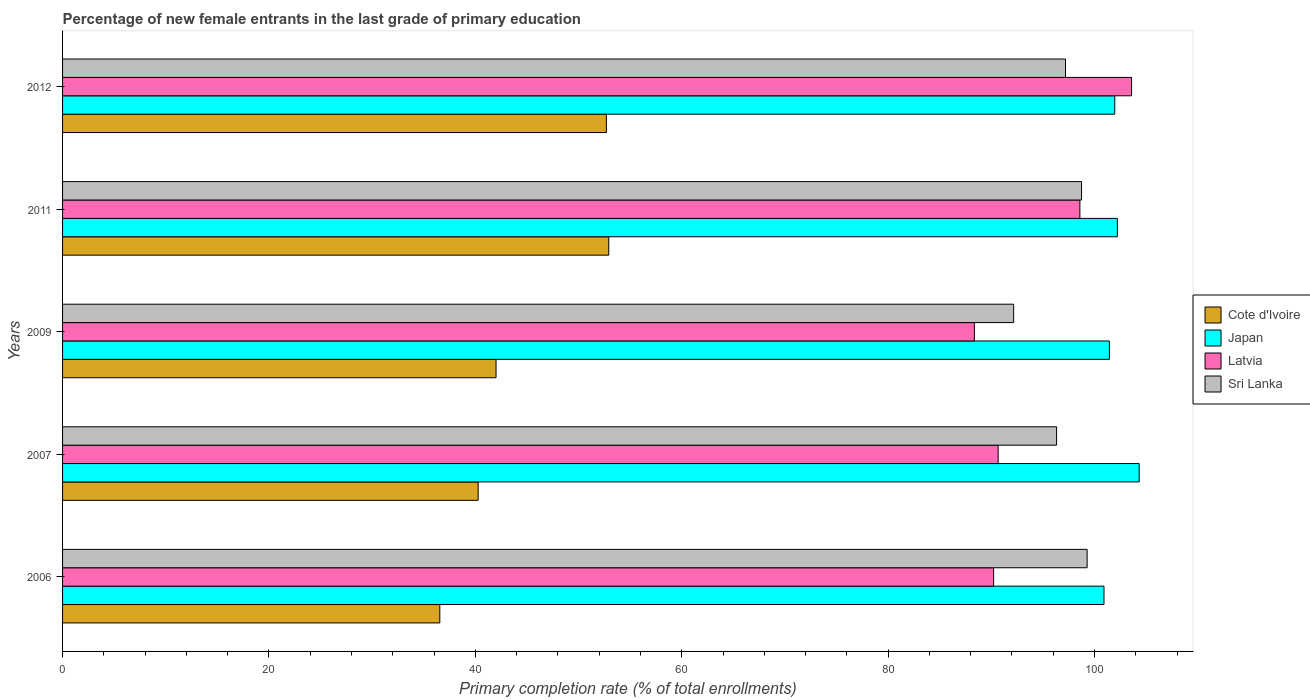How many different coloured bars are there?
Give a very brief answer. 4. Are the number of bars on each tick of the Y-axis equal?
Provide a succinct answer. Yes. How many bars are there on the 2nd tick from the top?
Provide a succinct answer. 4. How many bars are there on the 3rd tick from the bottom?
Your response must be concise. 4. What is the label of the 5th group of bars from the top?
Make the answer very short. 2006. What is the percentage of new female entrants in Japan in 2007?
Your answer should be compact. 104.33. Across all years, what is the maximum percentage of new female entrants in Cote d'Ivoire?
Ensure brevity in your answer.  52.93. Across all years, what is the minimum percentage of new female entrants in Japan?
Give a very brief answer. 100.92. In which year was the percentage of new female entrants in Sri Lanka maximum?
Your answer should be very brief. 2006. What is the total percentage of new female entrants in Japan in the graph?
Offer a terse response. 510.86. What is the difference between the percentage of new female entrants in Latvia in 2006 and that in 2009?
Offer a terse response. 1.86. What is the difference between the percentage of new female entrants in Cote d'Ivoire in 2006 and the percentage of new female entrants in Japan in 2009?
Keep it short and to the point. -64.89. What is the average percentage of new female entrants in Japan per year?
Ensure brevity in your answer.  102.17. In the year 2006, what is the difference between the percentage of new female entrants in Latvia and percentage of new female entrants in Sri Lanka?
Make the answer very short. -9.06. What is the ratio of the percentage of new female entrants in Japan in 2009 to that in 2011?
Provide a short and direct response. 0.99. Is the percentage of new female entrants in Cote d'Ivoire in 2006 less than that in 2009?
Make the answer very short. Yes. Is the difference between the percentage of new female entrants in Latvia in 2009 and 2012 greater than the difference between the percentage of new female entrants in Sri Lanka in 2009 and 2012?
Your answer should be compact. No. What is the difference between the highest and the second highest percentage of new female entrants in Latvia?
Provide a short and direct response. 5.01. What is the difference between the highest and the lowest percentage of new female entrants in Sri Lanka?
Provide a short and direct response. 7.12. In how many years, is the percentage of new female entrants in Sri Lanka greater than the average percentage of new female entrants in Sri Lanka taken over all years?
Offer a terse response. 3. What does the 4th bar from the top in 2011 represents?
Ensure brevity in your answer.  Cote d'Ivoire. What does the 3rd bar from the bottom in 2006 represents?
Provide a short and direct response. Latvia. Is it the case that in every year, the sum of the percentage of new female entrants in Cote d'Ivoire and percentage of new female entrants in Japan is greater than the percentage of new female entrants in Sri Lanka?
Make the answer very short. Yes. How many years are there in the graph?
Keep it short and to the point. 5. What is the difference between two consecutive major ticks on the X-axis?
Ensure brevity in your answer.  20. Are the values on the major ticks of X-axis written in scientific E-notation?
Keep it short and to the point. No. Does the graph contain any zero values?
Offer a terse response. No. Does the graph contain grids?
Offer a terse response. No. How are the legend labels stacked?
Keep it short and to the point. Vertical. What is the title of the graph?
Provide a succinct answer. Percentage of new female entrants in the last grade of primary education. What is the label or title of the X-axis?
Offer a very short reply. Primary completion rate (% of total enrollments). What is the label or title of the Y-axis?
Your answer should be compact. Years. What is the Primary completion rate (% of total enrollments) in Cote d'Ivoire in 2006?
Offer a very short reply. 36.56. What is the Primary completion rate (% of total enrollments) in Japan in 2006?
Offer a terse response. 100.92. What is the Primary completion rate (% of total enrollments) of Latvia in 2006?
Your answer should be very brief. 90.22. What is the Primary completion rate (% of total enrollments) in Sri Lanka in 2006?
Provide a short and direct response. 99.28. What is the Primary completion rate (% of total enrollments) in Cote d'Ivoire in 2007?
Your answer should be very brief. 40.27. What is the Primary completion rate (% of total enrollments) of Japan in 2007?
Offer a very short reply. 104.33. What is the Primary completion rate (% of total enrollments) in Latvia in 2007?
Keep it short and to the point. 90.66. What is the Primary completion rate (% of total enrollments) of Sri Lanka in 2007?
Make the answer very short. 96.32. What is the Primary completion rate (% of total enrollments) in Cote d'Ivoire in 2009?
Keep it short and to the point. 42.01. What is the Primary completion rate (% of total enrollments) in Japan in 2009?
Offer a very short reply. 101.44. What is the Primary completion rate (% of total enrollments) of Latvia in 2009?
Your answer should be very brief. 88.36. What is the Primary completion rate (% of total enrollments) of Sri Lanka in 2009?
Offer a terse response. 92.16. What is the Primary completion rate (% of total enrollments) of Cote d'Ivoire in 2011?
Your response must be concise. 52.93. What is the Primary completion rate (% of total enrollments) of Japan in 2011?
Offer a terse response. 102.21. What is the Primary completion rate (% of total enrollments) of Latvia in 2011?
Give a very brief answer. 98.58. What is the Primary completion rate (% of total enrollments) of Sri Lanka in 2011?
Your answer should be very brief. 98.74. What is the Primary completion rate (% of total enrollments) of Cote d'Ivoire in 2012?
Give a very brief answer. 52.7. What is the Primary completion rate (% of total enrollments) in Japan in 2012?
Offer a terse response. 101.96. What is the Primary completion rate (% of total enrollments) of Latvia in 2012?
Offer a very short reply. 103.59. What is the Primary completion rate (% of total enrollments) of Sri Lanka in 2012?
Your response must be concise. 97.19. Across all years, what is the maximum Primary completion rate (% of total enrollments) in Cote d'Ivoire?
Offer a terse response. 52.93. Across all years, what is the maximum Primary completion rate (% of total enrollments) in Japan?
Your answer should be very brief. 104.33. Across all years, what is the maximum Primary completion rate (% of total enrollments) of Latvia?
Provide a succinct answer. 103.59. Across all years, what is the maximum Primary completion rate (% of total enrollments) of Sri Lanka?
Your answer should be very brief. 99.28. Across all years, what is the minimum Primary completion rate (% of total enrollments) of Cote d'Ivoire?
Your response must be concise. 36.56. Across all years, what is the minimum Primary completion rate (% of total enrollments) in Japan?
Give a very brief answer. 100.92. Across all years, what is the minimum Primary completion rate (% of total enrollments) of Latvia?
Your answer should be very brief. 88.36. Across all years, what is the minimum Primary completion rate (% of total enrollments) of Sri Lanka?
Your answer should be compact. 92.16. What is the total Primary completion rate (% of total enrollments) of Cote d'Ivoire in the graph?
Provide a short and direct response. 224.46. What is the total Primary completion rate (% of total enrollments) in Japan in the graph?
Your answer should be compact. 510.86. What is the total Primary completion rate (% of total enrollments) of Latvia in the graph?
Provide a succinct answer. 471.41. What is the total Primary completion rate (% of total enrollments) in Sri Lanka in the graph?
Provide a succinct answer. 483.7. What is the difference between the Primary completion rate (% of total enrollments) of Cote d'Ivoire in 2006 and that in 2007?
Provide a succinct answer. -3.72. What is the difference between the Primary completion rate (% of total enrollments) of Japan in 2006 and that in 2007?
Keep it short and to the point. -3.41. What is the difference between the Primary completion rate (% of total enrollments) of Latvia in 2006 and that in 2007?
Provide a short and direct response. -0.44. What is the difference between the Primary completion rate (% of total enrollments) of Sri Lanka in 2006 and that in 2007?
Your response must be concise. 2.96. What is the difference between the Primary completion rate (% of total enrollments) in Cote d'Ivoire in 2006 and that in 2009?
Make the answer very short. -5.45. What is the difference between the Primary completion rate (% of total enrollments) of Japan in 2006 and that in 2009?
Give a very brief answer. -0.52. What is the difference between the Primary completion rate (% of total enrollments) in Latvia in 2006 and that in 2009?
Your response must be concise. 1.86. What is the difference between the Primary completion rate (% of total enrollments) in Sri Lanka in 2006 and that in 2009?
Offer a very short reply. 7.12. What is the difference between the Primary completion rate (% of total enrollments) of Cote d'Ivoire in 2006 and that in 2011?
Your response must be concise. -16.37. What is the difference between the Primary completion rate (% of total enrollments) of Japan in 2006 and that in 2011?
Your answer should be compact. -1.3. What is the difference between the Primary completion rate (% of total enrollments) of Latvia in 2006 and that in 2011?
Offer a very short reply. -8.36. What is the difference between the Primary completion rate (% of total enrollments) in Sri Lanka in 2006 and that in 2011?
Your answer should be very brief. 0.54. What is the difference between the Primary completion rate (% of total enrollments) of Cote d'Ivoire in 2006 and that in 2012?
Your answer should be very brief. -16.14. What is the difference between the Primary completion rate (% of total enrollments) of Japan in 2006 and that in 2012?
Give a very brief answer. -1.04. What is the difference between the Primary completion rate (% of total enrollments) of Latvia in 2006 and that in 2012?
Keep it short and to the point. -13.37. What is the difference between the Primary completion rate (% of total enrollments) in Sri Lanka in 2006 and that in 2012?
Offer a terse response. 2.1. What is the difference between the Primary completion rate (% of total enrollments) in Cote d'Ivoire in 2007 and that in 2009?
Offer a terse response. -1.73. What is the difference between the Primary completion rate (% of total enrollments) of Japan in 2007 and that in 2009?
Provide a succinct answer. 2.89. What is the difference between the Primary completion rate (% of total enrollments) of Latvia in 2007 and that in 2009?
Offer a terse response. 2.3. What is the difference between the Primary completion rate (% of total enrollments) in Sri Lanka in 2007 and that in 2009?
Provide a succinct answer. 4.16. What is the difference between the Primary completion rate (% of total enrollments) of Cote d'Ivoire in 2007 and that in 2011?
Provide a succinct answer. -12.66. What is the difference between the Primary completion rate (% of total enrollments) of Japan in 2007 and that in 2011?
Give a very brief answer. 2.11. What is the difference between the Primary completion rate (% of total enrollments) of Latvia in 2007 and that in 2011?
Provide a succinct answer. -7.92. What is the difference between the Primary completion rate (% of total enrollments) in Sri Lanka in 2007 and that in 2011?
Make the answer very short. -2.42. What is the difference between the Primary completion rate (% of total enrollments) in Cote d'Ivoire in 2007 and that in 2012?
Provide a succinct answer. -12.43. What is the difference between the Primary completion rate (% of total enrollments) of Japan in 2007 and that in 2012?
Give a very brief answer. 2.37. What is the difference between the Primary completion rate (% of total enrollments) of Latvia in 2007 and that in 2012?
Provide a succinct answer. -12.93. What is the difference between the Primary completion rate (% of total enrollments) of Sri Lanka in 2007 and that in 2012?
Your response must be concise. -0.86. What is the difference between the Primary completion rate (% of total enrollments) in Cote d'Ivoire in 2009 and that in 2011?
Give a very brief answer. -10.92. What is the difference between the Primary completion rate (% of total enrollments) of Japan in 2009 and that in 2011?
Provide a succinct answer. -0.77. What is the difference between the Primary completion rate (% of total enrollments) of Latvia in 2009 and that in 2011?
Offer a terse response. -10.22. What is the difference between the Primary completion rate (% of total enrollments) in Sri Lanka in 2009 and that in 2011?
Make the answer very short. -6.58. What is the difference between the Primary completion rate (% of total enrollments) of Cote d'Ivoire in 2009 and that in 2012?
Provide a succinct answer. -10.69. What is the difference between the Primary completion rate (% of total enrollments) of Japan in 2009 and that in 2012?
Your answer should be compact. -0.52. What is the difference between the Primary completion rate (% of total enrollments) of Latvia in 2009 and that in 2012?
Make the answer very short. -15.23. What is the difference between the Primary completion rate (% of total enrollments) of Sri Lanka in 2009 and that in 2012?
Provide a succinct answer. -5.02. What is the difference between the Primary completion rate (% of total enrollments) of Cote d'Ivoire in 2011 and that in 2012?
Provide a short and direct response. 0.23. What is the difference between the Primary completion rate (% of total enrollments) of Japan in 2011 and that in 2012?
Offer a terse response. 0.25. What is the difference between the Primary completion rate (% of total enrollments) of Latvia in 2011 and that in 2012?
Your response must be concise. -5.01. What is the difference between the Primary completion rate (% of total enrollments) in Sri Lanka in 2011 and that in 2012?
Keep it short and to the point. 1.56. What is the difference between the Primary completion rate (% of total enrollments) of Cote d'Ivoire in 2006 and the Primary completion rate (% of total enrollments) of Japan in 2007?
Offer a very short reply. -67.77. What is the difference between the Primary completion rate (% of total enrollments) of Cote d'Ivoire in 2006 and the Primary completion rate (% of total enrollments) of Latvia in 2007?
Your answer should be compact. -54.11. What is the difference between the Primary completion rate (% of total enrollments) of Cote d'Ivoire in 2006 and the Primary completion rate (% of total enrollments) of Sri Lanka in 2007?
Provide a succinct answer. -59.77. What is the difference between the Primary completion rate (% of total enrollments) in Japan in 2006 and the Primary completion rate (% of total enrollments) in Latvia in 2007?
Keep it short and to the point. 10.26. What is the difference between the Primary completion rate (% of total enrollments) in Japan in 2006 and the Primary completion rate (% of total enrollments) in Sri Lanka in 2007?
Offer a very short reply. 4.6. What is the difference between the Primary completion rate (% of total enrollments) in Latvia in 2006 and the Primary completion rate (% of total enrollments) in Sri Lanka in 2007?
Provide a short and direct response. -6.1. What is the difference between the Primary completion rate (% of total enrollments) of Cote d'Ivoire in 2006 and the Primary completion rate (% of total enrollments) of Japan in 2009?
Offer a very short reply. -64.89. What is the difference between the Primary completion rate (% of total enrollments) of Cote d'Ivoire in 2006 and the Primary completion rate (% of total enrollments) of Latvia in 2009?
Keep it short and to the point. -51.8. What is the difference between the Primary completion rate (% of total enrollments) in Cote d'Ivoire in 2006 and the Primary completion rate (% of total enrollments) in Sri Lanka in 2009?
Give a very brief answer. -55.61. What is the difference between the Primary completion rate (% of total enrollments) of Japan in 2006 and the Primary completion rate (% of total enrollments) of Latvia in 2009?
Ensure brevity in your answer.  12.56. What is the difference between the Primary completion rate (% of total enrollments) of Japan in 2006 and the Primary completion rate (% of total enrollments) of Sri Lanka in 2009?
Provide a short and direct response. 8.75. What is the difference between the Primary completion rate (% of total enrollments) of Latvia in 2006 and the Primary completion rate (% of total enrollments) of Sri Lanka in 2009?
Your answer should be compact. -1.94. What is the difference between the Primary completion rate (% of total enrollments) in Cote d'Ivoire in 2006 and the Primary completion rate (% of total enrollments) in Japan in 2011?
Your response must be concise. -65.66. What is the difference between the Primary completion rate (% of total enrollments) in Cote d'Ivoire in 2006 and the Primary completion rate (% of total enrollments) in Latvia in 2011?
Your answer should be very brief. -62.03. What is the difference between the Primary completion rate (% of total enrollments) in Cote d'Ivoire in 2006 and the Primary completion rate (% of total enrollments) in Sri Lanka in 2011?
Offer a terse response. -62.19. What is the difference between the Primary completion rate (% of total enrollments) of Japan in 2006 and the Primary completion rate (% of total enrollments) of Latvia in 2011?
Make the answer very short. 2.34. What is the difference between the Primary completion rate (% of total enrollments) in Japan in 2006 and the Primary completion rate (% of total enrollments) in Sri Lanka in 2011?
Your answer should be very brief. 2.18. What is the difference between the Primary completion rate (% of total enrollments) of Latvia in 2006 and the Primary completion rate (% of total enrollments) of Sri Lanka in 2011?
Offer a very short reply. -8.52. What is the difference between the Primary completion rate (% of total enrollments) in Cote d'Ivoire in 2006 and the Primary completion rate (% of total enrollments) in Japan in 2012?
Make the answer very short. -65.41. What is the difference between the Primary completion rate (% of total enrollments) of Cote d'Ivoire in 2006 and the Primary completion rate (% of total enrollments) of Latvia in 2012?
Your response must be concise. -67.03. What is the difference between the Primary completion rate (% of total enrollments) in Cote d'Ivoire in 2006 and the Primary completion rate (% of total enrollments) in Sri Lanka in 2012?
Provide a succinct answer. -60.63. What is the difference between the Primary completion rate (% of total enrollments) of Japan in 2006 and the Primary completion rate (% of total enrollments) of Latvia in 2012?
Provide a short and direct response. -2.67. What is the difference between the Primary completion rate (% of total enrollments) of Japan in 2006 and the Primary completion rate (% of total enrollments) of Sri Lanka in 2012?
Make the answer very short. 3.73. What is the difference between the Primary completion rate (% of total enrollments) of Latvia in 2006 and the Primary completion rate (% of total enrollments) of Sri Lanka in 2012?
Provide a succinct answer. -6.97. What is the difference between the Primary completion rate (% of total enrollments) of Cote d'Ivoire in 2007 and the Primary completion rate (% of total enrollments) of Japan in 2009?
Ensure brevity in your answer.  -61.17. What is the difference between the Primary completion rate (% of total enrollments) of Cote d'Ivoire in 2007 and the Primary completion rate (% of total enrollments) of Latvia in 2009?
Ensure brevity in your answer.  -48.09. What is the difference between the Primary completion rate (% of total enrollments) in Cote d'Ivoire in 2007 and the Primary completion rate (% of total enrollments) in Sri Lanka in 2009?
Ensure brevity in your answer.  -51.89. What is the difference between the Primary completion rate (% of total enrollments) of Japan in 2007 and the Primary completion rate (% of total enrollments) of Latvia in 2009?
Make the answer very short. 15.97. What is the difference between the Primary completion rate (% of total enrollments) of Japan in 2007 and the Primary completion rate (% of total enrollments) of Sri Lanka in 2009?
Ensure brevity in your answer.  12.16. What is the difference between the Primary completion rate (% of total enrollments) in Latvia in 2007 and the Primary completion rate (% of total enrollments) in Sri Lanka in 2009?
Give a very brief answer. -1.5. What is the difference between the Primary completion rate (% of total enrollments) in Cote d'Ivoire in 2007 and the Primary completion rate (% of total enrollments) in Japan in 2011?
Provide a succinct answer. -61.94. What is the difference between the Primary completion rate (% of total enrollments) of Cote d'Ivoire in 2007 and the Primary completion rate (% of total enrollments) of Latvia in 2011?
Your response must be concise. -58.31. What is the difference between the Primary completion rate (% of total enrollments) in Cote d'Ivoire in 2007 and the Primary completion rate (% of total enrollments) in Sri Lanka in 2011?
Make the answer very short. -58.47. What is the difference between the Primary completion rate (% of total enrollments) of Japan in 2007 and the Primary completion rate (% of total enrollments) of Latvia in 2011?
Offer a very short reply. 5.75. What is the difference between the Primary completion rate (% of total enrollments) in Japan in 2007 and the Primary completion rate (% of total enrollments) in Sri Lanka in 2011?
Ensure brevity in your answer.  5.59. What is the difference between the Primary completion rate (% of total enrollments) of Latvia in 2007 and the Primary completion rate (% of total enrollments) of Sri Lanka in 2011?
Make the answer very short. -8.08. What is the difference between the Primary completion rate (% of total enrollments) in Cote d'Ivoire in 2007 and the Primary completion rate (% of total enrollments) in Japan in 2012?
Provide a succinct answer. -61.69. What is the difference between the Primary completion rate (% of total enrollments) in Cote d'Ivoire in 2007 and the Primary completion rate (% of total enrollments) in Latvia in 2012?
Your answer should be very brief. -63.32. What is the difference between the Primary completion rate (% of total enrollments) of Cote d'Ivoire in 2007 and the Primary completion rate (% of total enrollments) of Sri Lanka in 2012?
Provide a short and direct response. -56.92. What is the difference between the Primary completion rate (% of total enrollments) of Japan in 2007 and the Primary completion rate (% of total enrollments) of Latvia in 2012?
Offer a very short reply. 0.74. What is the difference between the Primary completion rate (% of total enrollments) of Japan in 2007 and the Primary completion rate (% of total enrollments) of Sri Lanka in 2012?
Keep it short and to the point. 7.14. What is the difference between the Primary completion rate (% of total enrollments) in Latvia in 2007 and the Primary completion rate (% of total enrollments) in Sri Lanka in 2012?
Offer a very short reply. -6.53. What is the difference between the Primary completion rate (% of total enrollments) in Cote d'Ivoire in 2009 and the Primary completion rate (% of total enrollments) in Japan in 2011?
Provide a succinct answer. -60.21. What is the difference between the Primary completion rate (% of total enrollments) in Cote d'Ivoire in 2009 and the Primary completion rate (% of total enrollments) in Latvia in 2011?
Keep it short and to the point. -56.58. What is the difference between the Primary completion rate (% of total enrollments) of Cote d'Ivoire in 2009 and the Primary completion rate (% of total enrollments) of Sri Lanka in 2011?
Your answer should be very brief. -56.74. What is the difference between the Primary completion rate (% of total enrollments) of Japan in 2009 and the Primary completion rate (% of total enrollments) of Latvia in 2011?
Ensure brevity in your answer.  2.86. What is the difference between the Primary completion rate (% of total enrollments) of Japan in 2009 and the Primary completion rate (% of total enrollments) of Sri Lanka in 2011?
Make the answer very short. 2.7. What is the difference between the Primary completion rate (% of total enrollments) in Latvia in 2009 and the Primary completion rate (% of total enrollments) in Sri Lanka in 2011?
Your answer should be compact. -10.39. What is the difference between the Primary completion rate (% of total enrollments) of Cote d'Ivoire in 2009 and the Primary completion rate (% of total enrollments) of Japan in 2012?
Provide a succinct answer. -59.96. What is the difference between the Primary completion rate (% of total enrollments) in Cote d'Ivoire in 2009 and the Primary completion rate (% of total enrollments) in Latvia in 2012?
Provide a short and direct response. -61.58. What is the difference between the Primary completion rate (% of total enrollments) of Cote d'Ivoire in 2009 and the Primary completion rate (% of total enrollments) of Sri Lanka in 2012?
Your response must be concise. -55.18. What is the difference between the Primary completion rate (% of total enrollments) in Japan in 2009 and the Primary completion rate (% of total enrollments) in Latvia in 2012?
Provide a short and direct response. -2.15. What is the difference between the Primary completion rate (% of total enrollments) of Japan in 2009 and the Primary completion rate (% of total enrollments) of Sri Lanka in 2012?
Offer a terse response. 4.25. What is the difference between the Primary completion rate (% of total enrollments) in Latvia in 2009 and the Primary completion rate (% of total enrollments) in Sri Lanka in 2012?
Ensure brevity in your answer.  -8.83. What is the difference between the Primary completion rate (% of total enrollments) in Cote d'Ivoire in 2011 and the Primary completion rate (% of total enrollments) in Japan in 2012?
Offer a very short reply. -49.03. What is the difference between the Primary completion rate (% of total enrollments) of Cote d'Ivoire in 2011 and the Primary completion rate (% of total enrollments) of Latvia in 2012?
Make the answer very short. -50.66. What is the difference between the Primary completion rate (% of total enrollments) in Cote d'Ivoire in 2011 and the Primary completion rate (% of total enrollments) in Sri Lanka in 2012?
Provide a short and direct response. -44.26. What is the difference between the Primary completion rate (% of total enrollments) of Japan in 2011 and the Primary completion rate (% of total enrollments) of Latvia in 2012?
Ensure brevity in your answer.  -1.38. What is the difference between the Primary completion rate (% of total enrollments) in Japan in 2011 and the Primary completion rate (% of total enrollments) in Sri Lanka in 2012?
Provide a succinct answer. 5.03. What is the difference between the Primary completion rate (% of total enrollments) of Latvia in 2011 and the Primary completion rate (% of total enrollments) of Sri Lanka in 2012?
Give a very brief answer. 1.39. What is the average Primary completion rate (% of total enrollments) in Cote d'Ivoire per year?
Offer a very short reply. 44.89. What is the average Primary completion rate (% of total enrollments) in Japan per year?
Ensure brevity in your answer.  102.17. What is the average Primary completion rate (% of total enrollments) of Latvia per year?
Your answer should be very brief. 94.28. What is the average Primary completion rate (% of total enrollments) in Sri Lanka per year?
Keep it short and to the point. 96.74. In the year 2006, what is the difference between the Primary completion rate (% of total enrollments) in Cote d'Ivoire and Primary completion rate (% of total enrollments) in Japan?
Ensure brevity in your answer.  -64.36. In the year 2006, what is the difference between the Primary completion rate (% of total enrollments) of Cote d'Ivoire and Primary completion rate (% of total enrollments) of Latvia?
Keep it short and to the point. -53.67. In the year 2006, what is the difference between the Primary completion rate (% of total enrollments) of Cote d'Ivoire and Primary completion rate (% of total enrollments) of Sri Lanka?
Ensure brevity in your answer.  -62.73. In the year 2006, what is the difference between the Primary completion rate (% of total enrollments) in Japan and Primary completion rate (% of total enrollments) in Latvia?
Your answer should be very brief. 10.7. In the year 2006, what is the difference between the Primary completion rate (% of total enrollments) of Japan and Primary completion rate (% of total enrollments) of Sri Lanka?
Offer a terse response. 1.64. In the year 2006, what is the difference between the Primary completion rate (% of total enrollments) in Latvia and Primary completion rate (% of total enrollments) in Sri Lanka?
Ensure brevity in your answer.  -9.06. In the year 2007, what is the difference between the Primary completion rate (% of total enrollments) of Cote d'Ivoire and Primary completion rate (% of total enrollments) of Japan?
Provide a succinct answer. -64.06. In the year 2007, what is the difference between the Primary completion rate (% of total enrollments) in Cote d'Ivoire and Primary completion rate (% of total enrollments) in Latvia?
Your answer should be very brief. -50.39. In the year 2007, what is the difference between the Primary completion rate (% of total enrollments) of Cote d'Ivoire and Primary completion rate (% of total enrollments) of Sri Lanka?
Offer a terse response. -56.05. In the year 2007, what is the difference between the Primary completion rate (% of total enrollments) in Japan and Primary completion rate (% of total enrollments) in Latvia?
Offer a terse response. 13.67. In the year 2007, what is the difference between the Primary completion rate (% of total enrollments) of Japan and Primary completion rate (% of total enrollments) of Sri Lanka?
Your response must be concise. 8.01. In the year 2007, what is the difference between the Primary completion rate (% of total enrollments) in Latvia and Primary completion rate (% of total enrollments) in Sri Lanka?
Your response must be concise. -5.66. In the year 2009, what is the difference between the Primary completion rate (% of total enrollments) of Cote d'Ivoire and Primary completion rate (% of total enrollments) of Japan?
Provide a succinct answer. -59.44. In the year 2009, what is the difference between the Primary completion rate (% of total enrollments) in Cote d'Ivoire and Primary completion rate (% of total enrollments) in Latvia?
Offer a terse response. -46.35. In the year 2009, what is the difference between the Primary completion rate (% of total enrollments) in Cote d'Ivoire and Primary completion rate (% of total enrollments) in Sri Lanka?
Offer a terse response. -50.16. In the year 2009, what is the difference between the Primary completion rate (% of total enrollments) in Japan and Primary completion rate (% of total enrollments) in Latvia?
Keep it short and to the point. 13.08. In the year 2009, what is the difference between the Primary completion rate (% of total enrollments) in Japan and Primary completion rate (% of total enrollments) in Sri Lanka?
Your answer should be very brief. 9.28. In the year 2009, what is the difference between the Primary completion rate (% of total enrollments) in Latvia and Primary completion rate (% of total enrollments) in Sri Lanka?
Offer a terse response. -3.81. In the year 2011, what is the difference between the Primary completion rate (% of total enrollments) of Cote d'Ivoire and Primary completion rate (% of total enrollments) of Japan?
Offer a terse response. -49.28. In the year 2011, what is the difference between the Primary completion rate (% of total enrollments) of Cote d'Ivoire and Primary completion rate (% of total enrollments) of Latvia?
Provide a succinct answer. -45.65. In the year 2011, what is the difference between the Primary completion rate (% of total enrollments) of Cote d'Ivoire and Primary completion rate (% of total enrollments) of Sri Lanka?
Your response must be concise. -45.81. In the year 2011, what is the difference between the Primary completion rate (% of total enrollments) in Japan and Primary completion rate (% of total enrollments) in Latvia?
Offer a terse response. 3.63. In the year 2011, what is the difference between the Primary completion rate (% of total enrollments) in Japan and Primary completion rate (% of total enrollments) in Sri Lanka?
Keep it short and to the point. 3.47. In the year 2011, what is the difference between the Primary completion rate (% of total enrollments) in Latvia and Primary completion rate (% of total enrollments) in Sri Lanka?
Provide a succinct answer. -0.16. In the year 2012, what is the difference between the Primary completion rate (% of total enrollments) of Cote d'Ivoire and Primary completion rate (% of total enrollments) of Japan?
Offer a very short reply. -49.26. In the year 2012, what is the difference between the Primary completion rate (% of total enrollments) in Cote d'Ivoire and Primary completion rate (% of total enrollments) in Latvia?
Give a very brief answer. -50.89. In the year 2012, what is the difference between the Primary completion rate (% of total enrollments) in Cote d'Ivoire and Primary completion rate (% of total enrollments) in Sri Lanka?
Offer a terse response. -44.49. In the year 2012, what is the difference between the Primary completion rate (% of total enrollments) in Japan and Primary completion rate (% of total enrollments) in Latvia?
Offer a terse response. -1.63. In the year 2012, what is the difference between the Primary completion rate (% of total enrollments) of Japan and Primary completion rate (% of total enrollments) of Sri Lanka?
Offer a terse response. 4.77. In the year 2012, what is the difference between the Primary completion rate (% of total enrollments) of Latvia and Primary completion rate (% of total enrollments) of Sri Lanka?
Ensure brevity in your answer.  6.4. What is the ratio of the Primary completion rate (% of total enrollments) of Cote d'Ivoire in 2006 to that in 2007?
Provide a succinct answer. 0.91. What is the ratio of the Primary completion rate (% of total enrollments) in Japan in 2006 to that in 2007?
Your answer should be very brief. 0.97. What is the ratio of the Primary completion rate (% of total enrollments) in Latvia in 2006 to that in 2007?
Make the answer very short. 1. What is the ratio of the Primary completion rate (% of total enrollments) of Sri Lanka in 2006 to that in 2007?
Ensure brevity in your answer.  1.03. What is the ratio of the Primary completion rate (% of total enrollments) in Cote d'Ivoire in 2006 to that in 2009?
Keep it short and to the point. 0.87. What is the ratio of the Primary completion rate (% of total enrollments) of Latvia in 2006 to that in 2009?
Give a very brief answer. 1.02. What is the ratio of the Primary completion rate (% of total enrollments) in Sri Lanka in 2006 to that in 2009?
Offer a terse response. 1.08. What is the ratio of the Primary completion rate (% of total enrollments) in Cote d'Ivoire in 2006 to that in 2011?
Provide a short and direct response. 0.69. What is the ratio of the Primary completion rate (% of total enrollments) in Japan in 2006 to that in 2011?
Your response must be concise. 0.99. What is the ratio of the Primary completion rate (% of total enrollments) of Latvia in 2006 to that in 2011?
Provide a succinct answer. 0.92. What is the ratio of the Primary completion rate (% of total enrollments) of Sri Lanka in 2006 to that in 2011?
Give a very brief answer. 1.01. What is the ratio of the Primary completion rate (% of total enrollments) of Cote d'Ivoire in 2006 to that in 2012?
Keep it short and to the point. 0.69. What is the ratio of the Primary completion rate (% of total enrollments) of Japan in 2006 to that in 2012?
Offer a terse response. 0.99. What is the ratio of the Primary completion rate (% of total enrollments) of Latvia in 2006 to that in 2012?
Provide a succinct answer. 0.87. What is the ratio of the Primary completion rate (% of total enrollments) in Sri Lanka in 2006 to that in 2012?
Keep it short and to the point. 1.02. What is the ratio of the Primary completion rate (% of total enrollments) of Cote d'Ivoire in 2007 to that in 2009?
Offer a terse response. 0.96. What is the ratio of the Primary completion rate (% of total enrollments) of Japan in 2007 to that in 2009?
Provide a succinct answer. 1.03. What is the ratio of the Primary completion rate (% of total enrollments) in Latvia in 2007 to that in 2009?
Your response must be concise. 1.03. What is the ratio of the Primary completion rate (% of total enrollments) in Sri Lanka in 2007 to that in 2009?
Offer a very short reply. 1.05. What is the ratio of the Primary completion rate (% of total enrollments) of Cote d'Ivoire in 2007 to that in 2011?
Keep it short and to the point. 0.76. What is the ratio of the Primary completion rate (% of total enrollments) in Japan in 2007 to that in 2011?
Make the answer very short. 1.02. What is the ratio of the Primary completion rate (% of total enrollments) in Latvia in 2007 to that in 2011?
Your answer should be very brief. 0.92. What is the ratio of the Primary completion rate (% of total enrollments) of Sri Lanka in 2007 to that in 2011?
Your answer should be compact. 0.98. What is the ratio of the Primary completion rate (% of total enrollments) of Cote d'Ivoire in 2007 to that in 2012?
Provide a short and direct response. 0.76. What is the ratio of the Primary completion rate (% of total enrollments) in Japan in 2007 to that in 2012?
Give a very brief answer. 1.02. What is the ratio of the Primary completion rate (% of total enrollments) of Latvia in 2007 to that in 2012?
Your answer should be compact. 0.88. What is the ratio of the Primary completion rate (% of total enrollments) in Sri Lanka in 2007 to that in 2012?
Offer a very short reply. 0.99. What is the ratio of the Primary completion rate (% of total enrollments) in Cote d'Ivoire in 2009 to that in 2011?
Keep it short and to the point. 0.79. What is the ratio of the Primary completion rate (% of total enrollments) in Japan in 2009 to that in 2011?
Your response must be concise. 0.99. What is the ratio of the Primary completion rate (% of total enrollments) in Latvia in 2009 to that in 2011?
Give a very brief answer. 0.9. What is the ratio of the Primary completion rate (% of total enrollments) of Sri Lanka in 2009 to that in 2011?
Your answer should be very brief. 0.93. What is the ratio of the Primary completion rate (% of total enrollments) in Cote d'Ivoire in 2009 to that in 2012?
Keep it short and to the point. 0.8. What is the ratio of the Primary completion rate (% of total enrollments) of Latvia in 2009 to that in 2012?
Provide a short and direct response. 0.85. What is the ratio of the Primary completion rate (% of total enrollments) in Sri Lanka in 2009 to that in 2012?
Offer a terse response. 0.95. What is the ratio of the Primary completion rate (% of total enrollments) of Cote d'Ivoire in 2011 to that in 2012?
Offer a terse response. 1. What is the ratio of the Primary completion rate (% of total enrollments) in Latvia in 2011 to that in 2012?
Offer a very short reply. 0.95. What is the ratio of the Primary completion rate (% of total enrollments) of Sri Lanka in 2011 to that in 2012?
Keep it short and to the point. 1.02. What is the difference between the highest and the second highest Primary completion rate (% of total enrollments) in Cote d'Ivoire?
Your answer should be compact. 0.23. What is the difference between the highest and the second highest Primary completion rate (% of total enrollments) in Japan?
Your response must be concise. 2.11. What is the difference between the highest and the second highest Primary completion rate (% of total enrollments) in Latvia?
Ensure brevity in your answer.  5.01. What is the difference between the highest and the second highest Primary completion rate (% of total enrollments) in Sri Lanka?
Make the answer very short. 0.54. What is the difference between the highest and the lowest Primary completion rate (% of total enrollments) of Cote d'Ivoire?
Offer a very short reply. 16.37. What is the difference between the highest and the lowest Primary completion rate (% of total enrollments) in Japan?
Your answer should be very brief. 3.41. What is the difference between the highest and the lowest Primary completion rate (% of total enrollments) of Latvia?
Ensure brevity in your answer.  15.23. What is the difference between the highest and the lowest Primary completion rate (% of total enrollments) of Sri Lanka?
Offer a very short reply. 7.12. 